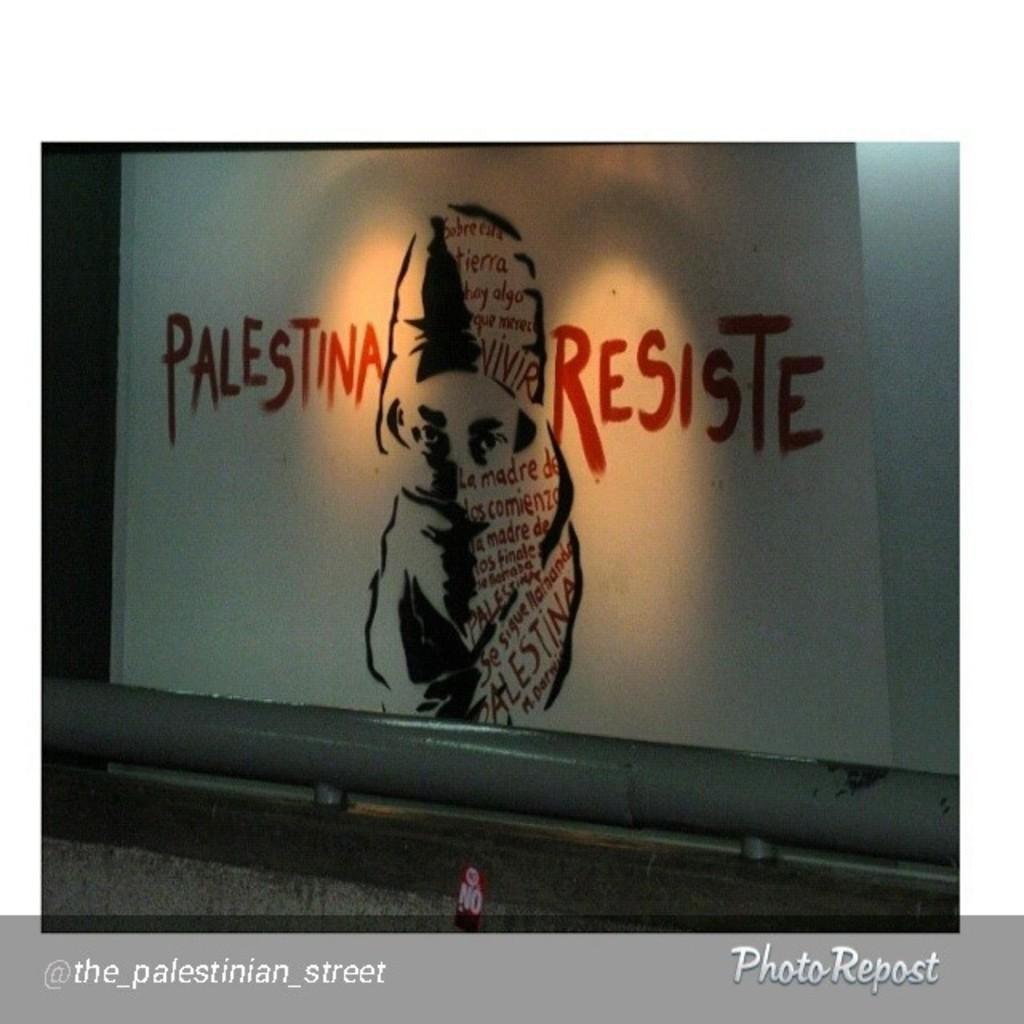How would you summarize this image in a sentence or two? In this picture we can see the white projector screen. On the screen we can see the woman covering her face with cloth and slogan is written. 